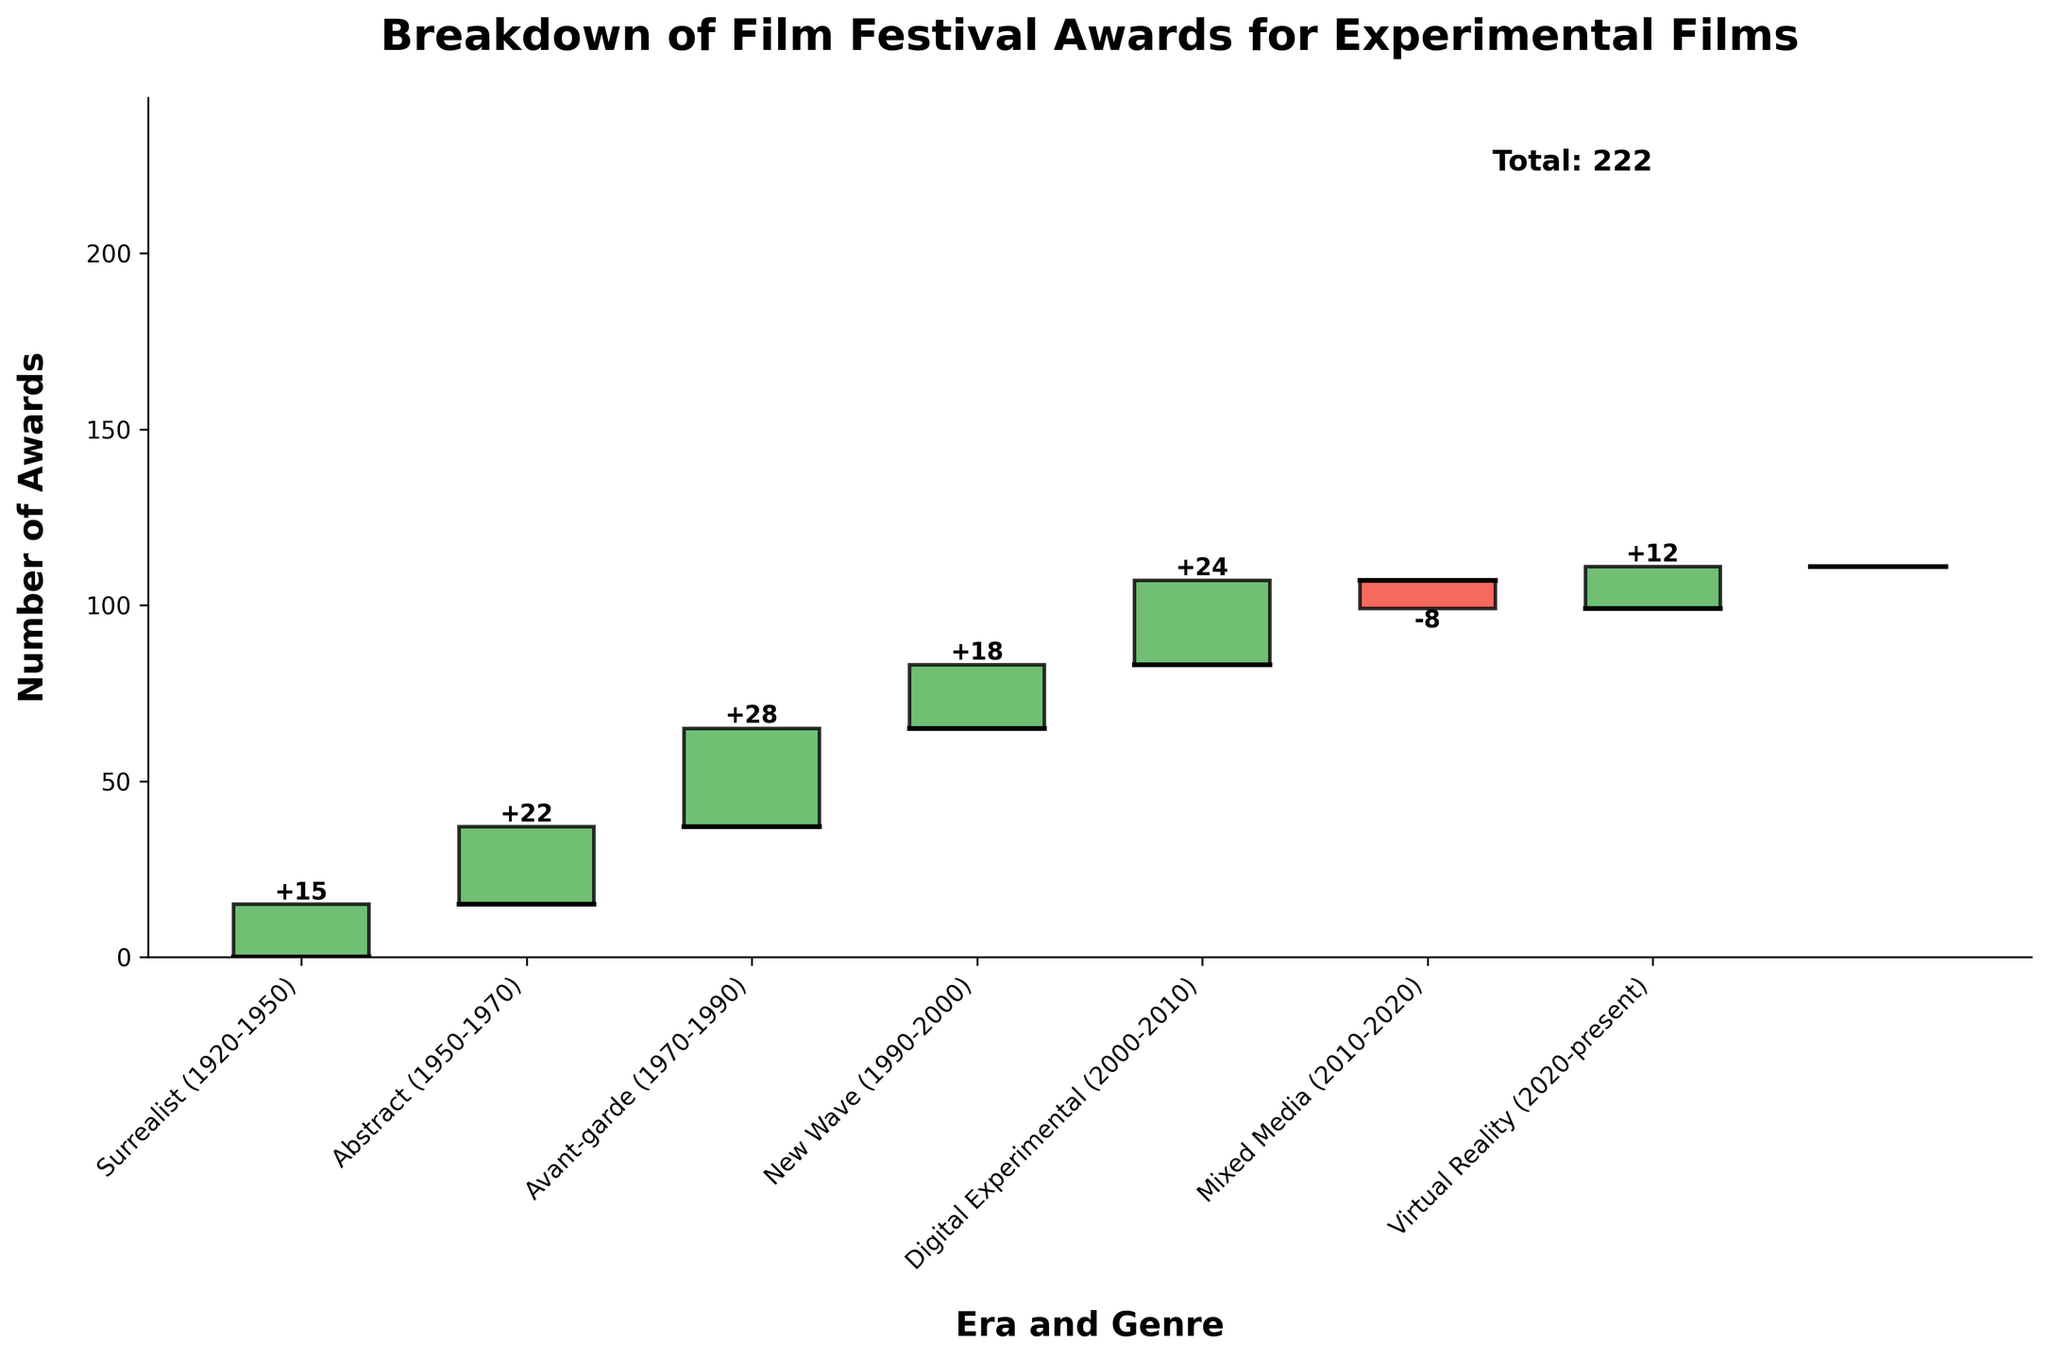What is the title of the figure? The title of the figure is located at the top center and is usually in bold font. The text reads: 'Breakdown of Film Festival Awards for Experimental Films'.
Answer: Breakdown of Film Festival Awards for Experimental Films What is the total number of awards for New Wave (1990-2000) experimental films? To find this, look at the bar labeled 'New Wave (1990-2000)'. The y-axis value associated with it indicates the number of awards, which is shown as +18 on the bar.
Answer: 18 What genre and era had the most negative impact on the total number of awards? Examine all bars to identify the one with the largest negative value. The 'Mixed Media (2010-2020)' category shows a -8 value, which is the only negative value and thus the most negative impact.
Answer: Mixed Media (2010-2020) How many total awards are there from 1920 to 1990? Sum the awards for 'Surrealist (1920-1950)', 'Abstract (1950-1970)', and 'Avant-garde (1970-1990)'. The values are 15, 22, and 28 respectively, so 15 + 22 + 28 = 65.
Answer: 65 What is the final total number of awards after summing all changes? The final total can be seen directly in the figure, typically at the end of the waterfall chart, labeled 'Total'. The y-axis value and text near this show that the number is 111.
Answer: 111 Which era showed a recovery in the total number of awards after 'Mixed Media (2010-2020)'? After 'Mixed Media (2010-2020)', look at the next category, 'Virtual Reality (2020-present)'. It shows a positive value (+12), indicating recovery.
Answer: Virtual Reality (2020-present) Which eras experienced growth in the number of awards for experimental films? Identify categories with positive values: 'Surrealist (1920-1950)', 'Abstract (1950-1970)', 'Avant-garde (1970-1990)', 'New Wave (1990-2000)', and 'Digital Experimental (2000-2010)', all show positive growth.
Answer: Surrealist, Abstract, Avant-garde, New Wave, Digital Experimental How does the number of awards in 'Surrealist (1920-1950)' compare to that in 'Virtual Reality (2020-present)'? Compare the two values: 'Surrealist (1920-1950)' is 15 and 'Virtual Reality (2020-present)' is 12. 15 is greater than 12.
Answer: 15 > 12 By how much did the awards for 'Digital Experimental (2000-2010)' change compared to 'New Wave (1990-2000)'? Subtract the value of 'New Wave (1990-2000)' from 'Digital Experimental (2000-2010)': 24 - 18 = 6.
Answer: 6 